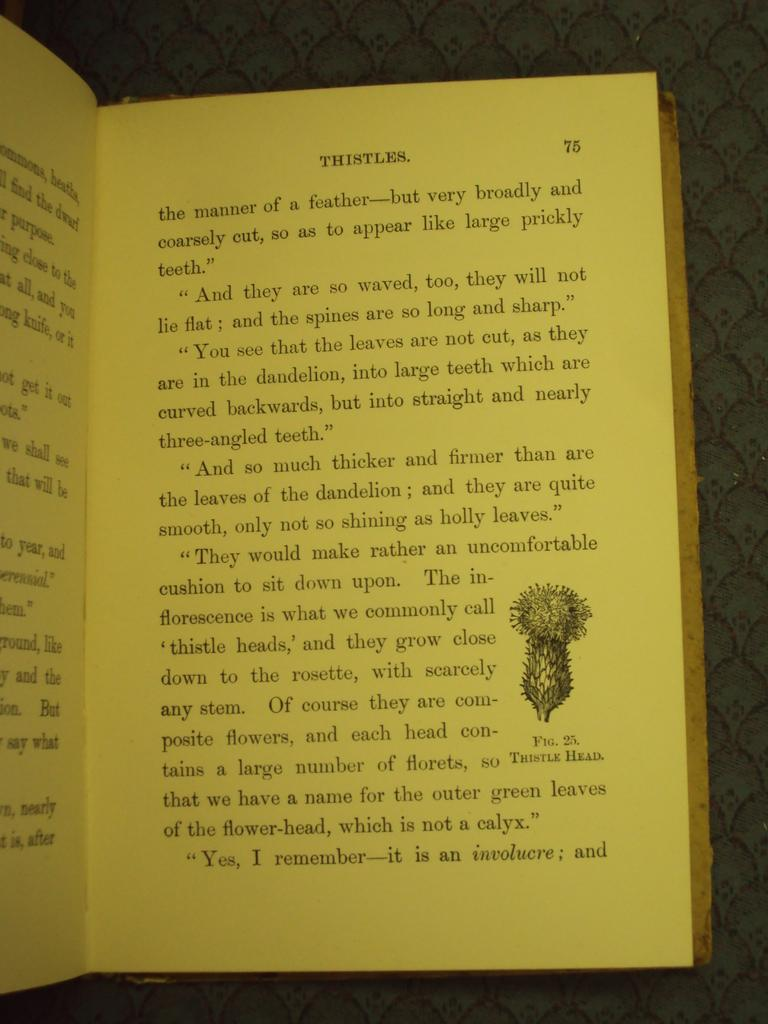What is the color of the book in the image? The book in the image is yellow. What is the color of the text on the book? The text on the book is black. Is there any image on the book? Yes, there is an image on the book. Can you see any steam coming from the book in the image? There is no steam present in the image; it features a book with an image and text. 